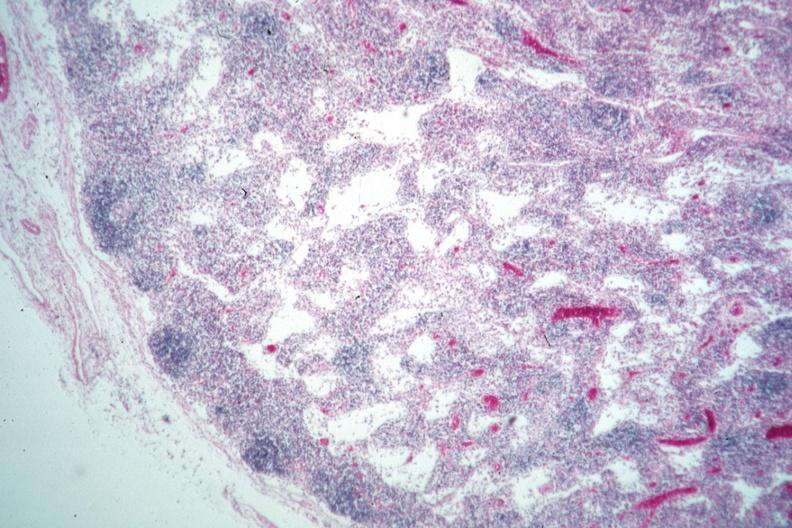s side showing patency right side present?
Answer the question using a single word or phrase. No 